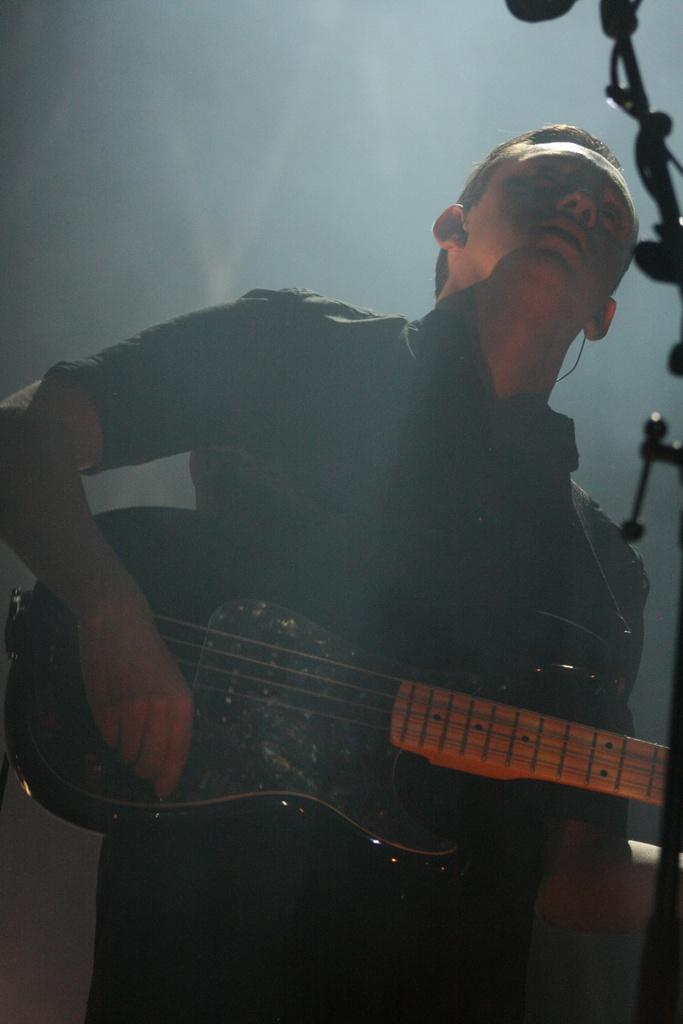What is the main subject of the image? The main subject of the image is a boy. Where is the boy positioned in the image? The boy is standing at the center of the image. What is the boy holding in his hand? The boy is holding a guitar in his hand. What type of bag is the laborer carrying in the image? There is no laborer or bag present in the image; it features a boy holding a guitar. What color is the silver object on the ground in the image? There is no silver object present in the image. 